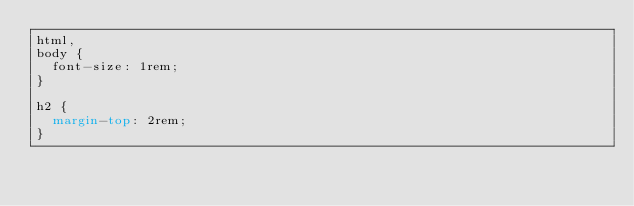Convert code to text. <code><loc_0><loc_0><loc_500><loc_500><_CSS_>html,
body {
  font-size: 1rem;
}

h2 {
  margin-top: 2rem;
}
</code> 